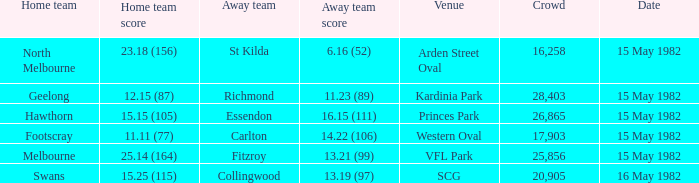What were the away team's points in the game with footscray? 14.22 (106). 